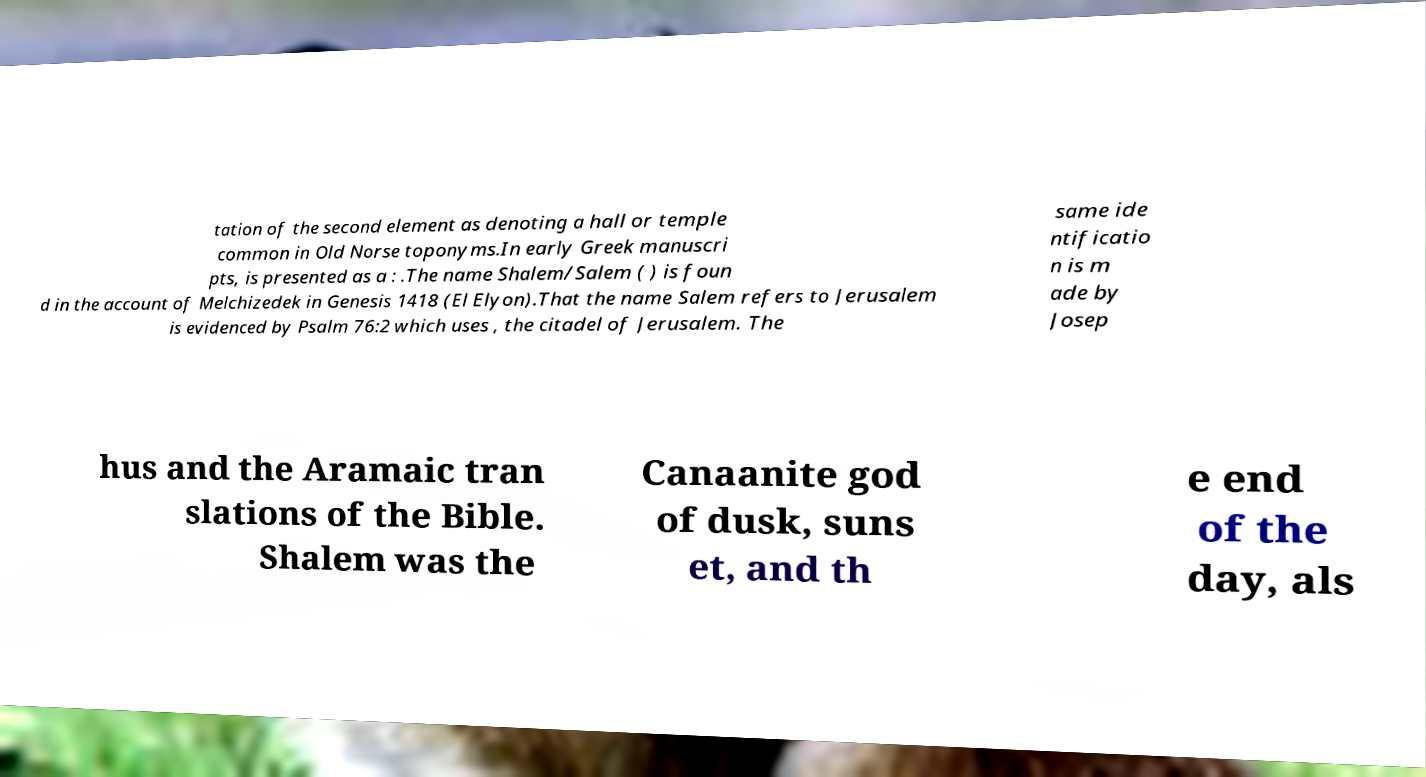For documentation purposes, I need the text within this image transcribed. Could you provide that? tation of the second element as denoting a hall or temple common in Old Norse toponyms.In early Greek manuscri pts, is presented as a : .The name Shalem/Salem ( ) is foun d in the account of Melchizedek in Genesis 1418 (El Elyon).That the name Salem refers to Jerusalem is evidenced by Psalm 76:2 which uses , the citadel of Jerusalem. The same ide ntificatio n is m ade by Josep hus and the Aramaic tran slations of the Bible. Shalem was the Canaanite god of dusk, suns et, and th e end of the day, als 